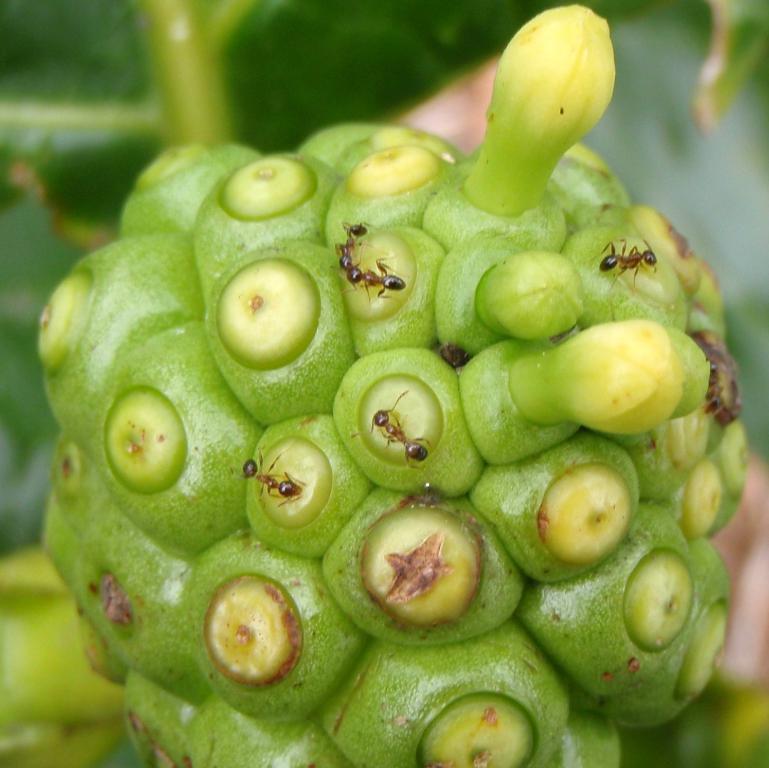Please provide a concise description of this image. This is a part of a plant where I can see two buds to it and I can see few and on this. On the top of this image a green color leaf is visible. 